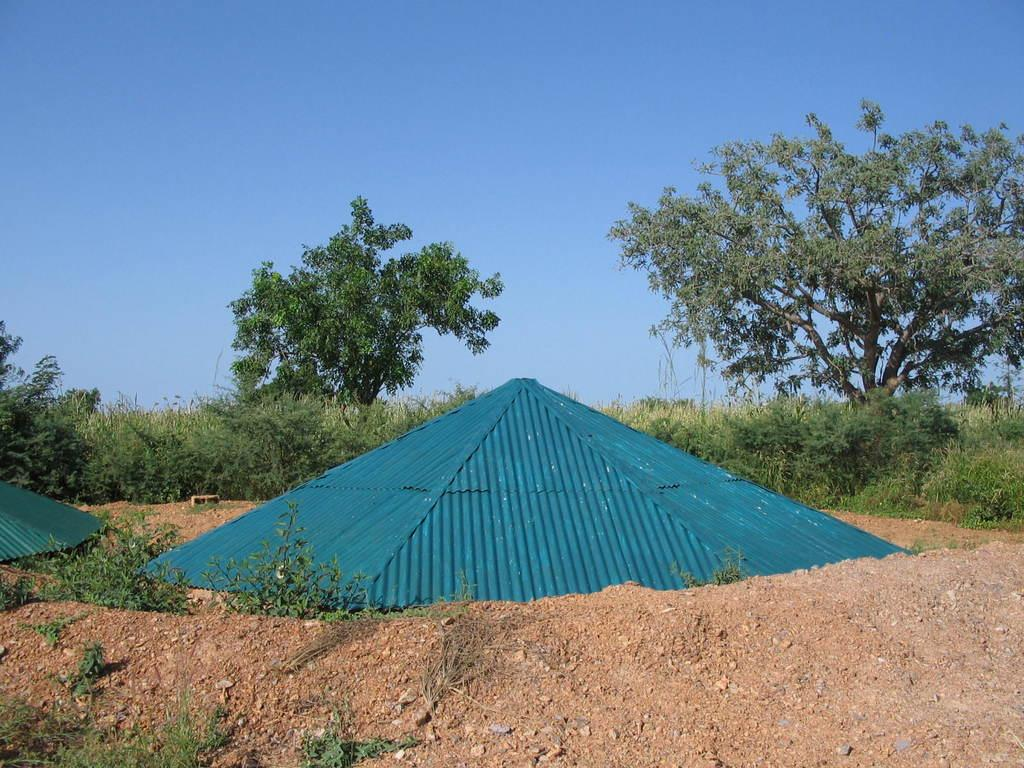What can be seen in the front of the image? There are objects in the front of the image. What type of vegetation is visible in the background of the image? There are plants and trees in the background of the image. What type of soap is being used to clean the trees in the image? There is no soap or cleaning activity depicted in the image; it features plants and trees in the background. What type of wine is being served with the plants in the image? There is no wine or serving activity depicted in the image; it features plants and trees in the background. 